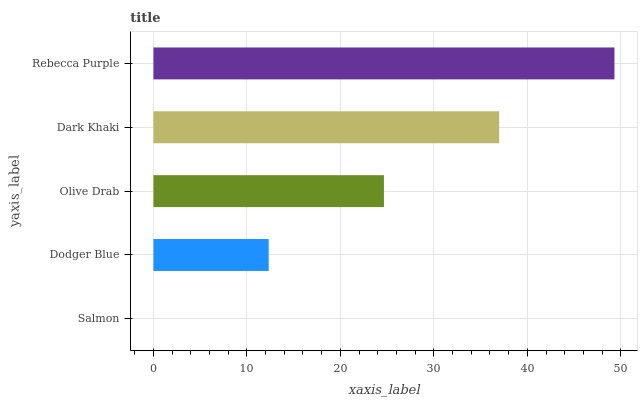Is Salmon the minimum?
Answer yes or no. Yes. Is Rebecca Purple the maximum?
Answer yes or no. Yes. Is Dodger Blue the minimum?
Answer yes or no. No. Is Dodger Blue the maximum?
Answer yes or no. No. Is Dodger Blue greater than Salmon?
Answer yes or no. Yes. Is Salmon less than Dodger Blue?
Answer yes or no. Yes. Is Salmon greater than Dodger Blue?
Answer yes or no. No. Is Dodger Blue less than Salmon?
Answer yes or no. No. Is Olive Drab the high median?
Answer yes or no. Yes. Is Olive Drab the low median?
Answer yes or no. Yes. Is Dodger Blue the high median?
Answer yes or no. No. Is Dodger Blue the low median?
Answer yes or no. No. 